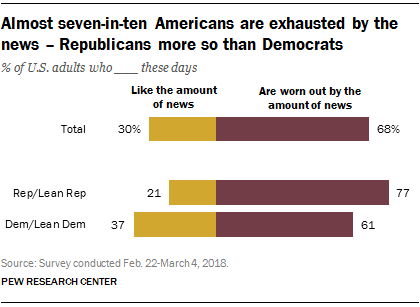Point out several critical features in this image. The yellow bar in the Total category represents 30% of the total value. The sum of the median of the yellow bars and the largest yellow bar is 67. 